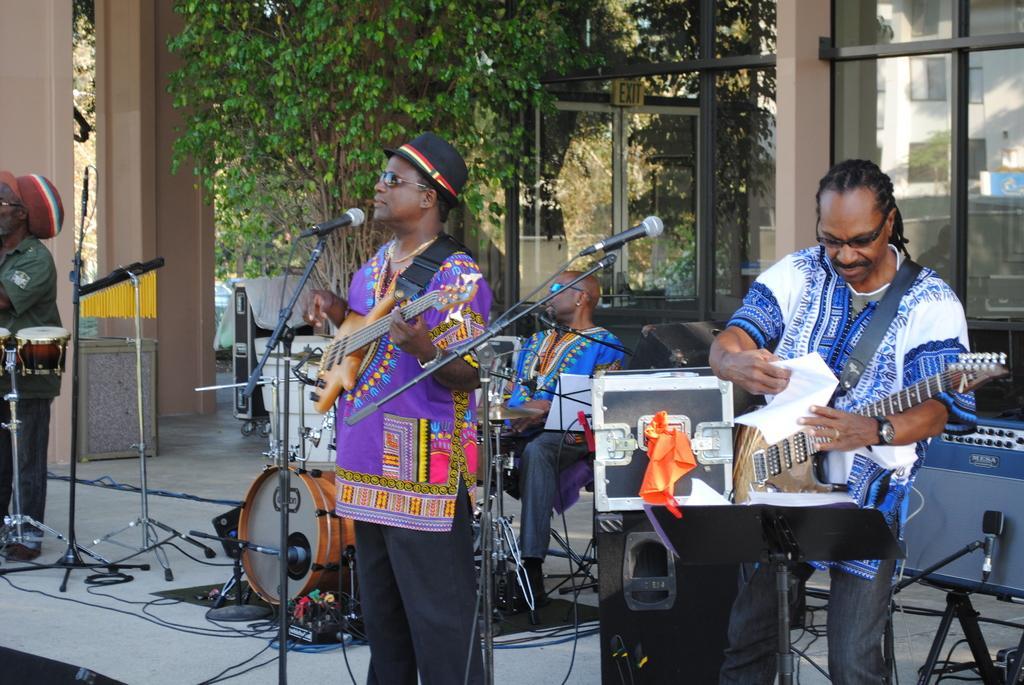In one or two sentences, can you explain what this image depicts? In this image I see 4 men in which these two are holding guitars and this man is holding a paper and I see this man is sitting and he is near to the drums and I see two mics over here. In the background I see the building and few equipment and the trees. 